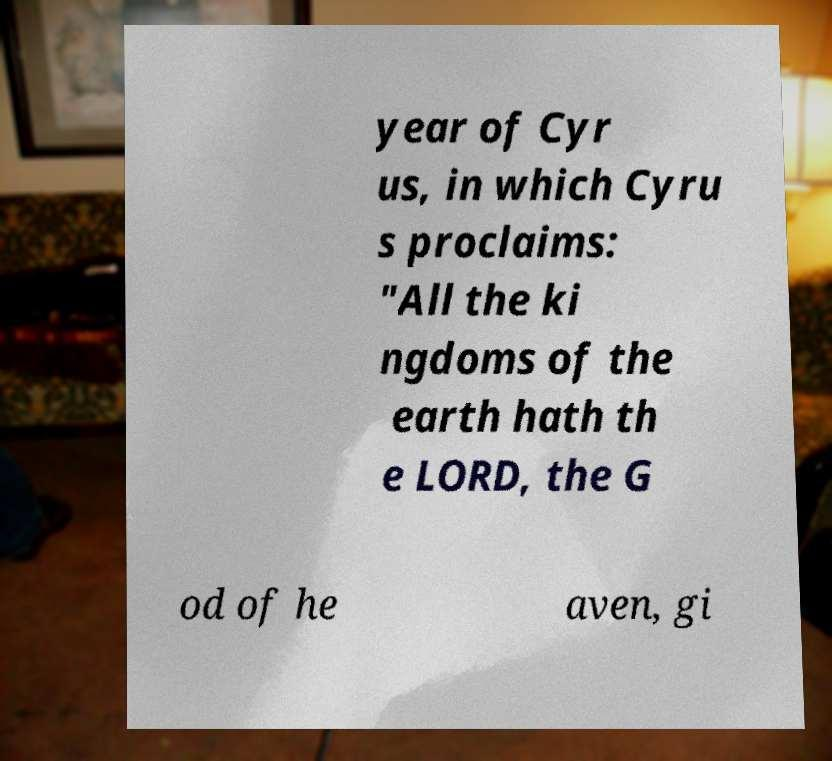Can you accurately transcribe the text from the provided image for me? year of Cyr us, in which Cyru s proclaims: "All the ki ngdoms of the earth hath th e LORD, the G od of he aven, gi 